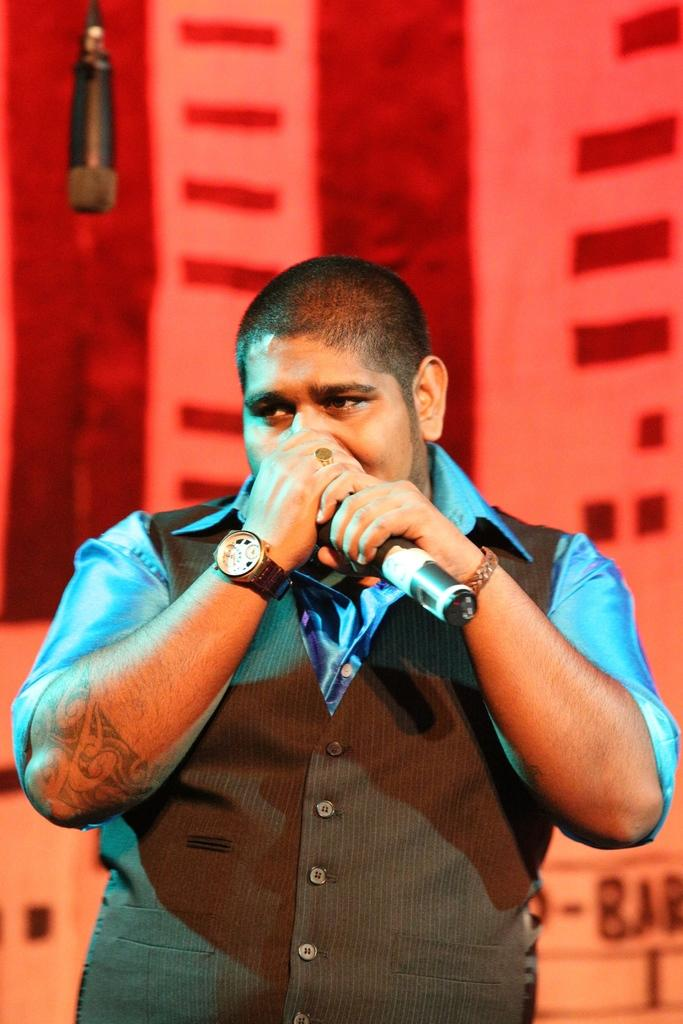What is the man in the image holding? The man is holding a mic. Where is the mic positioned in relation to the man? The mic is near the man's mouth. What type of food is on the plate in the image? There is no plate or food present in the image; it only features a man holding a mic. 